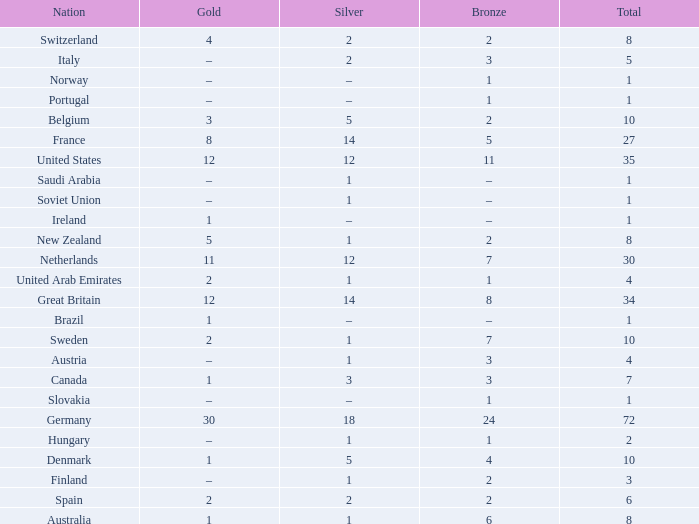What is the total number of Total, when Silver is 1, and when Bronze is 7? 1.0. 